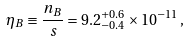<formula> <loc_0><loc_0><loc_500><loc_500>\eta _ { B } \equiv \frac { n _ { B } } { s } = 9 . 2 ^ { + 0 . 6 } _ { - 0 . 4 } \times 1 0 ^ { - 1 1 } \, ,</formula> 